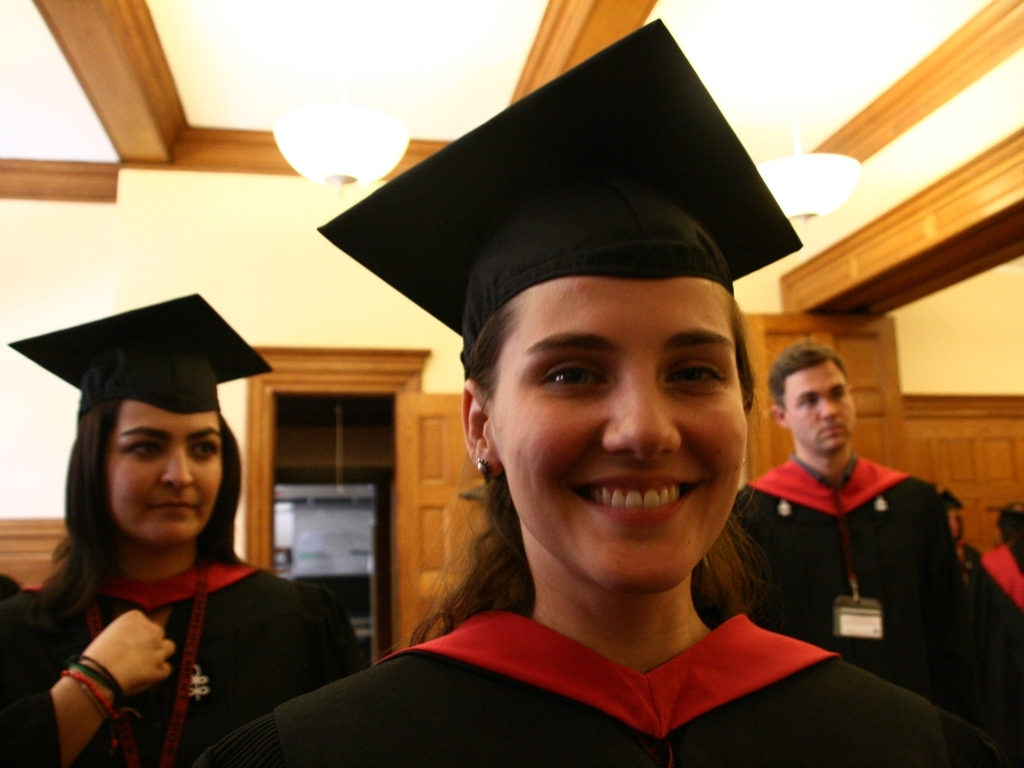Could you describe the expressions or mood of the people in the photo? The individual in the foreground has a broad smile and bright, engaging eyes, suggesting she is experiencing joy and pride on this significant day. The woman in the background shows a more subdued expression, which might indicate contemplation or calmness amidst the celebration. The man’s posture and distant gaze suggest he might be lost in thought or focused on something outside the frame. 